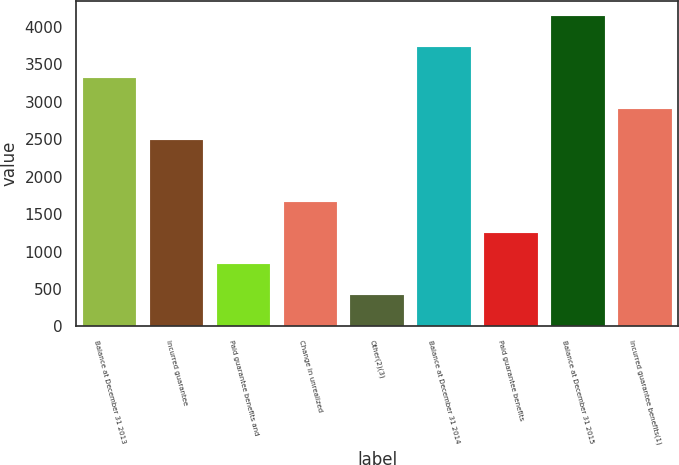Convert chart. <chart><loc_0><loc_0><loc_500><loc_500><bar_chart><fcel>Balance at December 31 2013<fcel>Incurred guarantee<fcel>Paid guarantee benefits and<fcel>Change in unrealized<fcel>Other(2)(3)<fcel>Balance at December 31 2014<fcel>Paid guarantee benefits<fcel>Balance at December 31 2015<fcel>Incurred guarantee benefits(1)<nl><fcel>3314.78<fcel>2486.57<fcel>830.16<fcel>1658.37<fcel>416.06<fcel>3728.89<fcel>1244.26<fcel>4142.99<fcel>2900.68<nl></chart> 